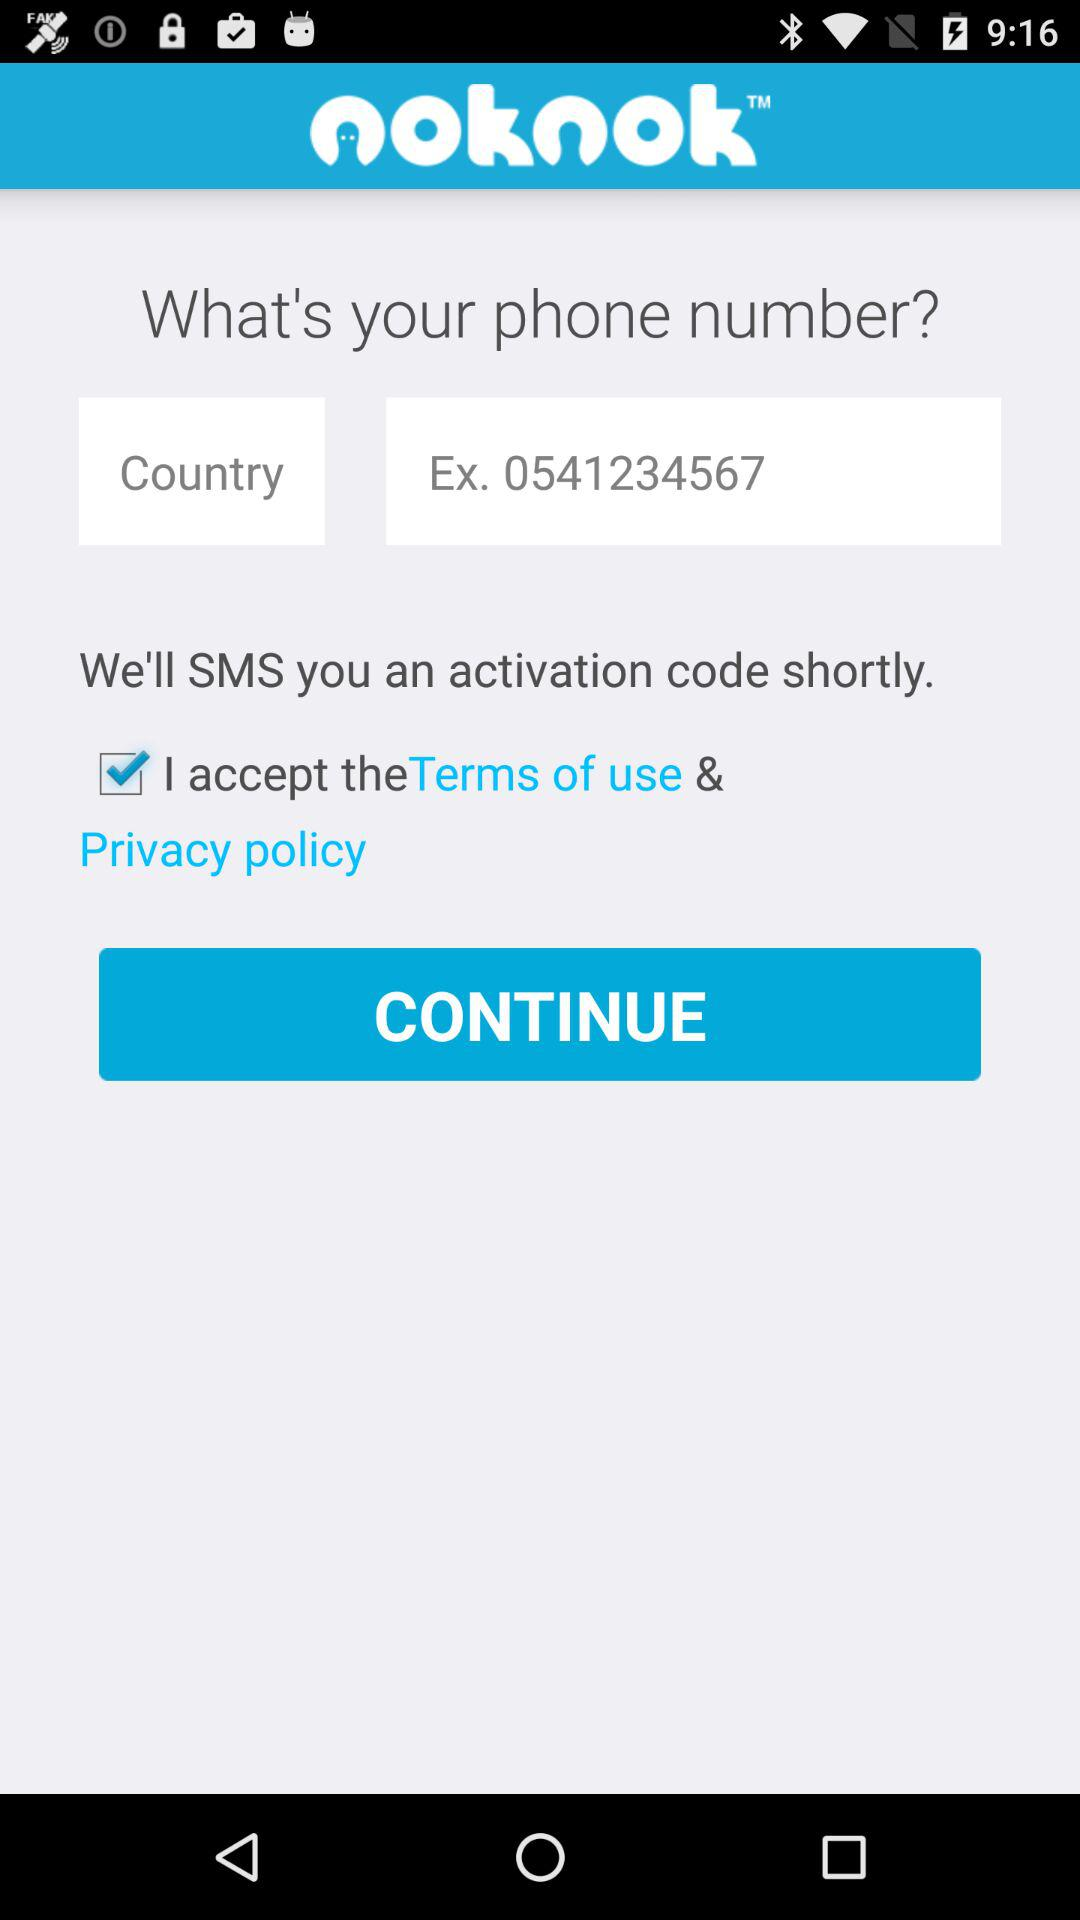What is the app name? The app name is "noknok". 